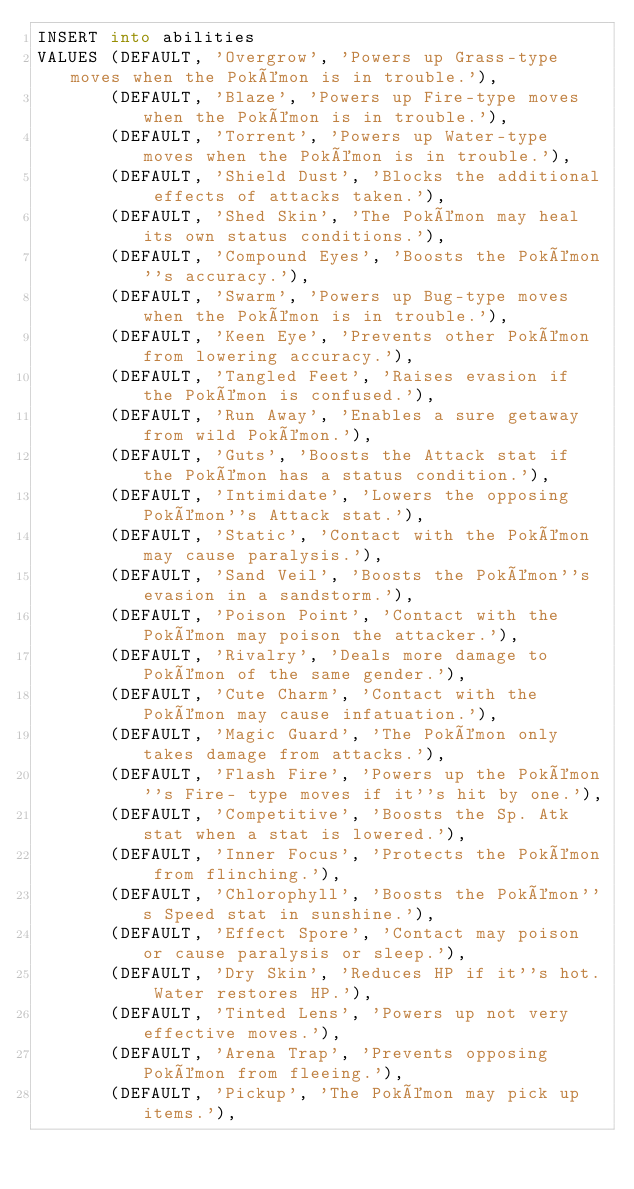<code> <loc_0><loc_0><loc_500><loc_500><_SQL_>INSERT into abilities
VALUES (DEFAULT, 'Overgrow', 'Powers up Grass-type moves when the Pokémon is in trouble.'),
       (DEFAULT, 'Blaze', 'Powers up Fire-type moves when the Pokémon is in trouble.'),
       (DEFAULT, 'Torrent', 'Powers up Water-type moves when the Pokémon is in trouble.'),
       (DEFAULT, 'Shield Dust', 'Blocks the additional effects of attacks taken.'),
       (DEFAULT, 'Shed Skin', 'The Pokémon may heal its own status conditions.'),
       (DEFAULT, 'Compound Eyes', 'Boosts the Pokémon''s accuracy.'),
       (DEFAULT, 'Swarm', 'Powers up Bug-type moves when the Pokémon is in trouble.'),
       (DEFAULT, 'Keen Eye', 'Prevents other Pokémon from lowering accuracy.'),
       (DEFAULT, 'Tangled Feet', 'Raises evasion if the Pokémon is confused.'),
       (DEFAULT, 'Run Away', 'Enables a sure getaway from wild Pokémon.'),
       (DEFAULT, 'Guts', 'Boosts the Attack stat if the Pokémon has a status condition.'),
       (DEFAULT, 'Intimidate', 'Lowers the opposing Pokémon''s Attack stat.'),
       (DEFAULT, 'Static', 'Contact with the Pokémon may cause paralysis.'),
       (DEFAULT, 'Sand Veil', 'Boosts the Pokémon''s evasion in a sandstorm.'),
       (DEFAULT, 'Poison Point', 'Contact with the Pokémon may poison the attacker.'),
       (DEFAULT, 'Rivalry', 'Deals more damage to Pokémon of the same gender.'),
       (DEFAULT, 'Cute Charm', 'Contact with the Pokémon may cause infatuation.'),
       (DEFAULT, 'Magic Guard', 'The Pokémon only takes damage from attacks.'),
       (DEFAULT, 'Flash Fire', 'Powers up the Pokémon''s Fire- type moves if it''s hit by one.'),
       (DEFAULT, 'Competitive', 'Boosts the Sp. Atk stat when a stat is lowered.'),
       (DEFAULT, 'Inner Focus', 'Protects the Pokémon from flinching.'),
       (DEFAULT, 'Chlorophyll', 'Boosts the Pokémon''s Speed stat in sunshine.'),
       (DEFAULT, 'Effect Spore', 'Contact may poison or cause paralysis or sleep.'),
       (DEFAULT, 'Dry Skin', 'Reduces HP if it''s hot. Water restores HP.'),
       (DEFAULT, 'Tinted Lens', 'Powers up not very effective moves.'),
       (DEFAULT, 'Arena Trap', 'Prevents opposing Pokémon from fleeing.'),
       (DEFAULT, 'Pickup', 'The Pokémon may pick up items.'),</code> 